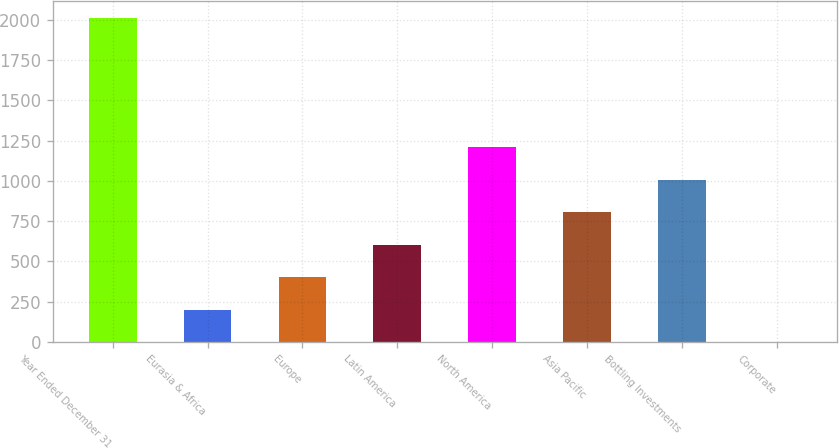<chart> <loc_0><loc_0><loc_500><loc_500><bar_chart><fcel>Year Ended December 31<fcel>Eurasia & Africa<fcel>Europe<fcel>Latin America<fcel>North America<fcel>Asia Pacific<fcel>Bottling Investments<fcel>Corporate<nl><fcel>2013<fcel>201.57<fcel>402.84<fcel>604.11<fcel>1207.92<fcel>805.38<fcel>1006.65<fcel>0.3<nl></chart> 